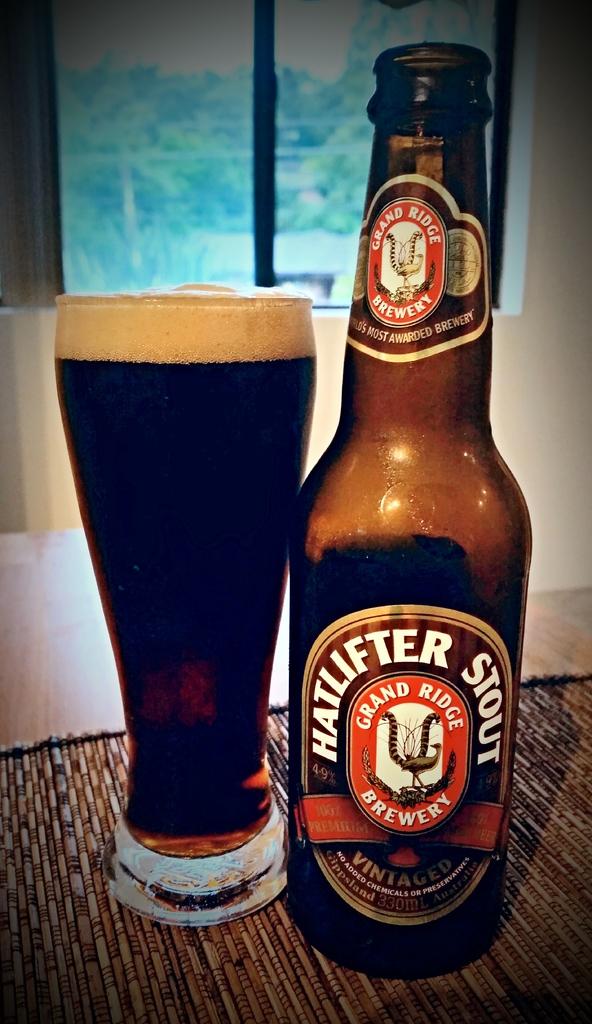What brewery is this stout from?
Make the answer very short. Grand ridge. What kind of beer is this?
Provide a succinct answer. Hatlifter stout. 